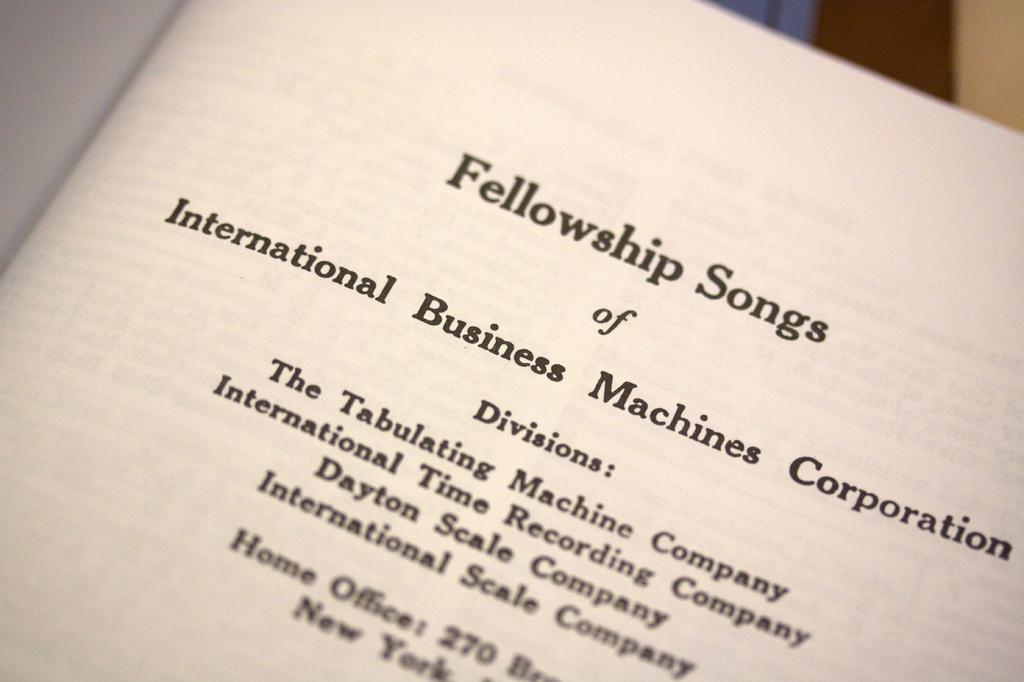<image>
Write a terse but informative summary of the picture. A book called Fellowship songs is open to the title page 